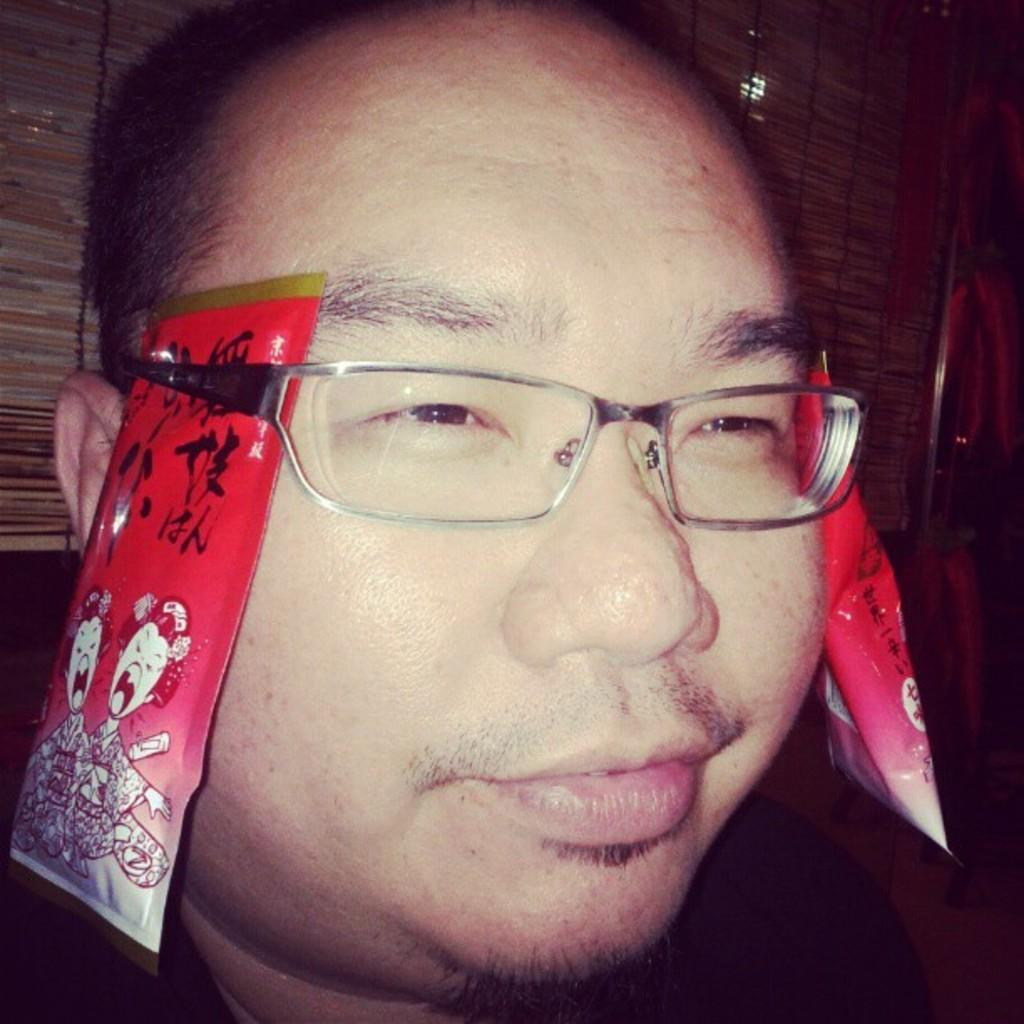Who is the main subject in the image? There is a man in the middle of the image. What is the man holding in the image? The man is holding spectacles. What else can be seen near the man in the image? There are two packets on either side of the man. How are the packets related to the spectacles? The packets are attached to the spectacles. What type of rule is being used to tie the knot on the bat in the image? There is no rule, knot, or bat present in the image. 